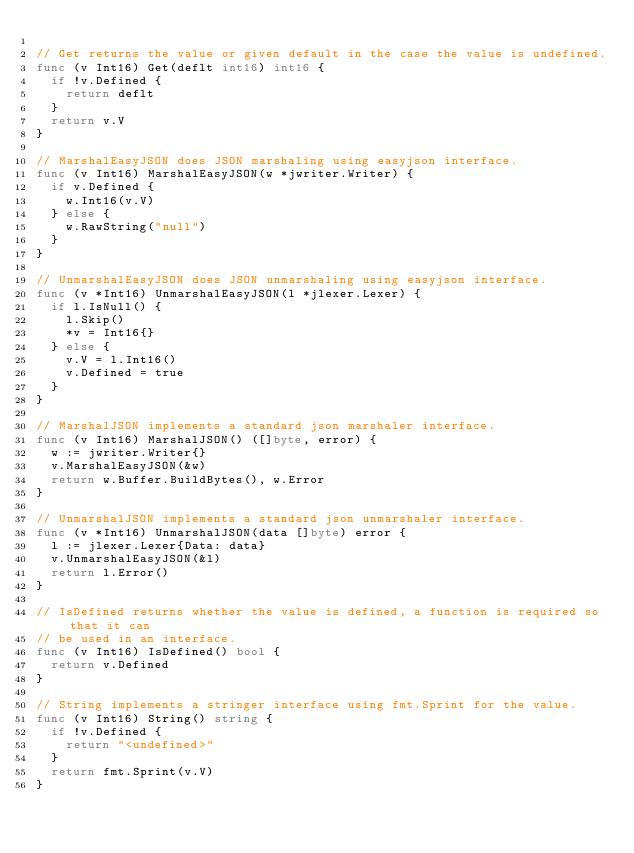Convert code to text. <code><loc_0><loc_0><loc_500><loc_500><_Go_>
// Get returns the value or given default in the case the value is undefined.
func (v Int16) Get(deflt int16) int16 {
	if !v.Defined {
		return deflt
	}
	return v.V
}

// MarshalEasyJSON does JSON marshaling using easyjson interface.
func (v Int16) MarshalEasyJSON(w *jwriter.Writer) {
	if v.Defined {
		w.Int16(v.V)
	} else {
		w.RawString("null")
	}
}

// UnmarshalEasyJSON does JSON unmarshaling using easyjson interface.
func (v *Int16) UnmarshalEasyJSON(l *jlexer.Lexer) {
	if l.IsNull() {
		l.Skip()
		*v = Int16{}
	} else {
		v.V = l.Int16()
		v.Defined = true
	}
}

// MarshalJSON implements a standard json marshaler interface.
func (v Int16) MarshalJSON() ([]byte, error) {
	w := jwriter.Writer{}
	v.MarshalEasyJSON(&w)
	return w.Buffer.BuildBytes(), w.Error
}

// UnmarshalJSON implements a standard json unmarshaler interface.
func (v *Int16) UnmarshalJSON(data []byte) error {
	l := jlexer.Lexer{Data: data}
	v.UnmarshalEasyJSON(&l)
	return l.Error()
}

// IsDefined returns whether the value is defined, a function is required so that it can
// be used in an interface.
func (v Int16) IsDefined() bool {
	return v.Defined
}

// String implements a stringer interface using fmt.Sprint for the value.
func (v Int16) String() string {
	if !v.Defined {
		return "<undefined>"
	}
	return fmt.Sprint(v.V)
}
</code> 